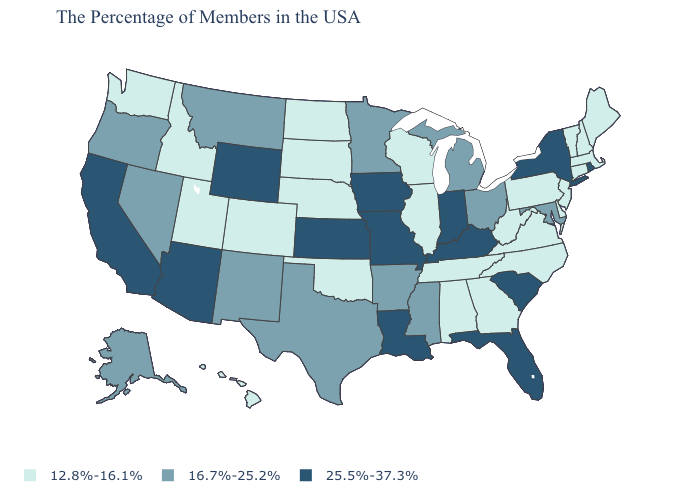Does Utah have the highest value in the West?
Concise answer only. No. Does Wyoming have the highest value in the USA?
Write a very short answer. Yes. Which states have the lowest value in the MidWest?
Be succinct. Wisconsin, Illinois, Nebraska, South Dakota, North Dakota. Among the states that border Georgia , does South Carolina have the highest value?
Give a very brief answer. Yes. How many symbols are there in the legend?
Concise answer only. 3. What is the value of Virginia?
Quick response, please. 12.8%-16.1%. Name the states that have a value in the range 25.5%-37.3%?
Keep it brief. Rhode Island, New York, South Carolina, Florida, Kentucky, Indiana, Louisiana, Missouri, Iowa, Kansas, Wyoming, Arizona, California. Name the states that have a value in the range 12.8%-16.1%?
Write a very short answer. Maine, Massachusetts, New Hampshire, Vermont, Connecticut, New Jersey, Delaware, Pennsylvania, Virginia, North Carolina, West Virginia, Georgia, Alabama, Tennessee, Wisconsin, Illinois, Nebraska, Oklahoma, South Dakota, North Dakota, Colorado, Utah, Idaho, Washington, Hawaii. Does Nevada have the highest value in the USA?
Give a very brief answer. No. Does Ohio have the same value as Kansas?
Be succinct. No. Does Iowa have the highest value in the USA?
Write a very short answer. Yes. What is the lowest value in states that border Maryland?
Answer briefly. 12.8%-16.1%. Among the states that border Vermont , does New York have the lowest value?
Keep it brief. No. How many symbols are there in the legend?
Concise answer only. 3. What is the lowest value in the USA?
Be succinct. 12.8%-16.1%. 